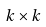Convert formula to latex. <formula><loc_0><loc_0><loc_500><loc_500>k \times k</formula> 